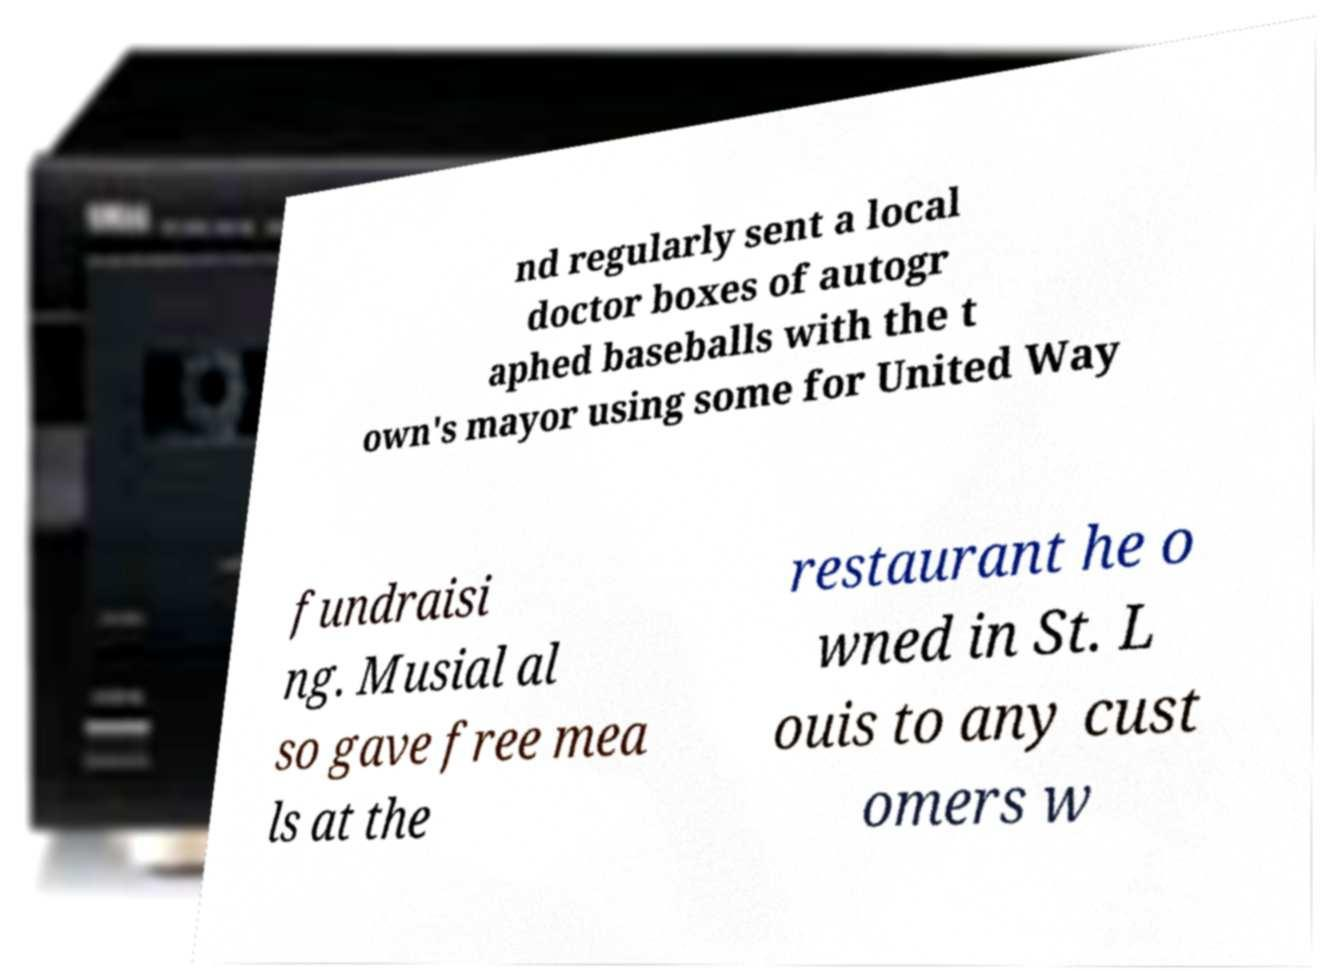Could you extract and type out the text from this image? nd regularly sent a local doctor boxes of autogr aphed baseballs with the t own's mayor using some for United Way fundraisi ng. Musial al so gave free mea ls at the restaurant he o wned in St. L ouis to any cust omers w 